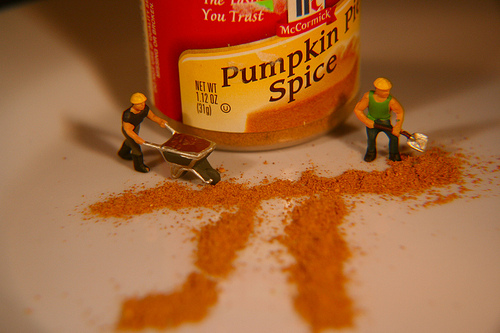<image>
Is there a pumpkin spice on the worker man? No. The pumpkin spice is not positioned on the worker man. They may be near each other, but the pumpkin spice is not supported by or resting on top of the worker man. Where is the man in relation to the spice? Is it in the spice? Yes. The man is contained within or inside the spice, showing a containment relationship. 